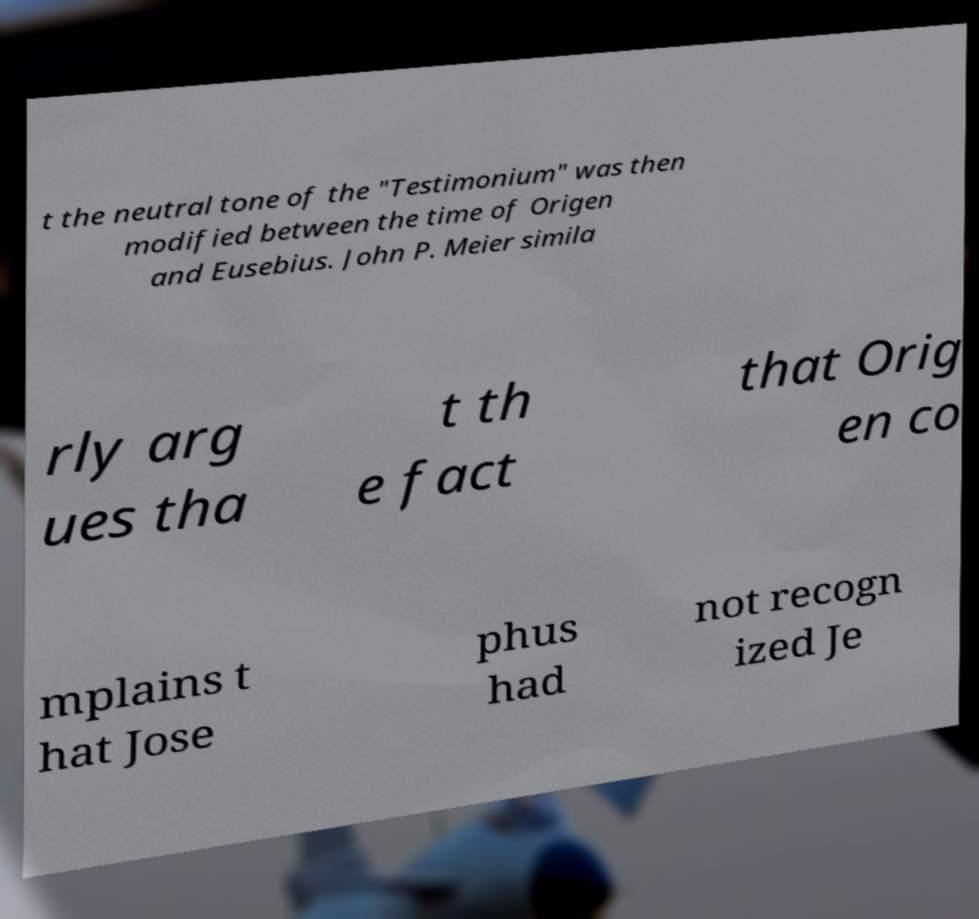For documentation purposes, I need the text within this image transcribed. Could you provide that? t the neutral tone of the "Testimonium" was then modified between the time of Origen and Eusebius. John P. Meier simila rly arg ues tha t th e fact that Orig en co mplains t hat Jose phus had not recogn ized Je 